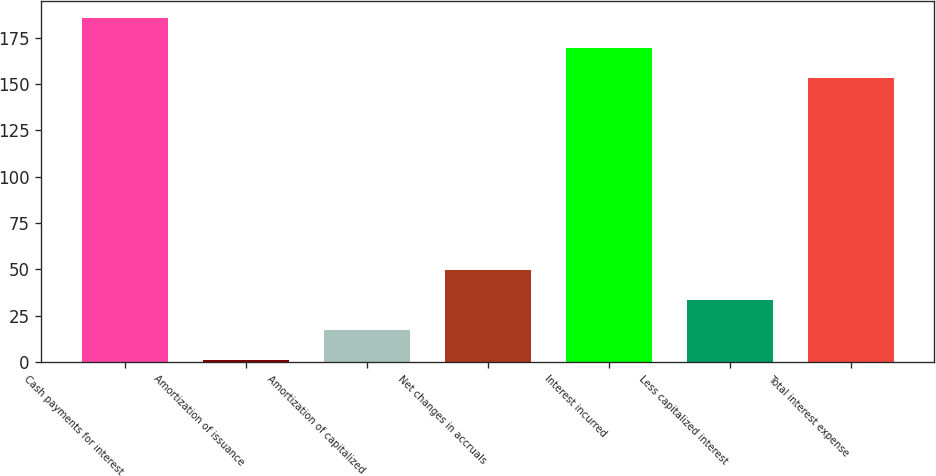Convert chart to OTSL. <chart><loc_0><loc_0><loc_500><loc_500><bar_chart><fcel>Cash payments for interest<fcel>Amortization of issuance<fcel>Amortization of capitalized<fcel>Net changes in accruals<fcel>Interest incurred<fcel>Less capitalized interest<fcel>Total interest expense<nl><fcel>185.6<fcel>1<fcel>17.3<fcel>49.9<fcel>169.3<fcel>33.6<fcel>153<nl></chart> 